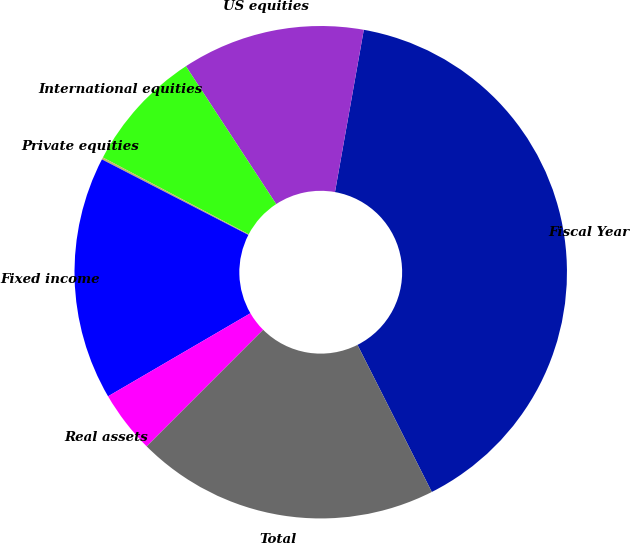Convert chart. <chart><loc_0><loc_0><loc_500><loc_500><pie_chart><fcel>Fiscal Year<fcel>US equities<fcel>International equities<fcel>Private equities<fcel>Fixed income<fcel>Real assets<fcel>Total<nl><fcel>39.75%<fcel>12.02%<fcel>8.06%<fcel>0.14%<fcel>15.98%<fcel>4.1%<fcel>19.94%<nl></chart> 